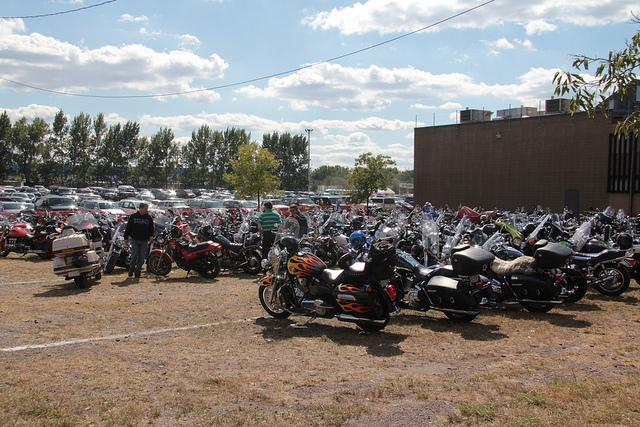The glare from the sun is distracting for drivers by reflecting off of what surface?

Choices:
A) pocket mirrors
B) cell phone
C) camera flash
D) motorcycle shields motorcycle shields 